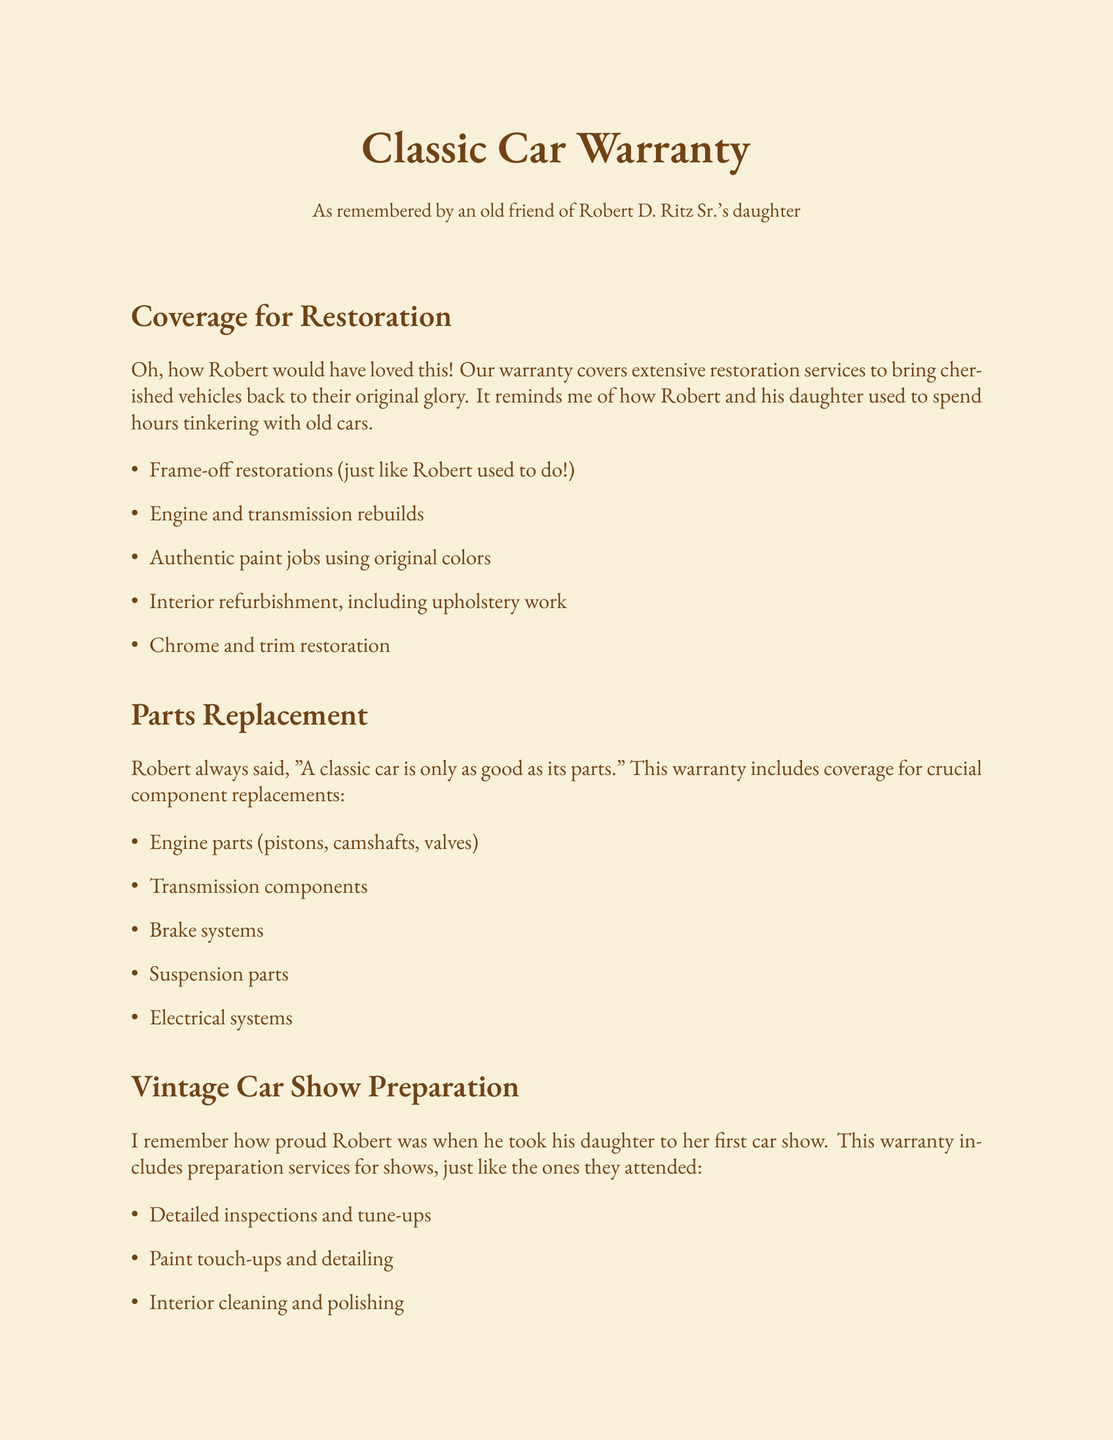What does the warranty cover for restoration? The document lists several restoration services included in the warranty, such as frame-off restorations and engine rebuilds.
Answer: Extensive restoration services How can you contact for details or claims? The document provides a contact method for inquiries related to the warranty, including a phone number and website.
Answer: 1-800-CLASSIC What is required for the warranty coverage? It states that regular inspections and maintenance are mandatory for the warranty to remain valid.
Answer: Regular inspections and maintenance What type of restoration is mentioned in the warranty? The warranty specifies several types of services, including frame-off restorations and engine rebuilds.
Answer: Frame-off restorations What is covered under parts replacement? The warranty includes coverage for important engine parts, which are listed in the document.
Answer: Engine parts What does the warranty provide for vintage car show preparation? The warranty outlines various preparation services to ensure a car is ready for shows, including detailed inspections.
Answer: Detailed inspections and tune-ups How should authentic paint jobs be done? The warranty emphasizes using original colors for paint jobs during restoration.
Answer: Using original colors When reminiscing, who would have loved the warranty? The document reflects fond memories, particularly of Robert and his daughter's shared experiences with classic cars.
Answer: Robert and his daughter 